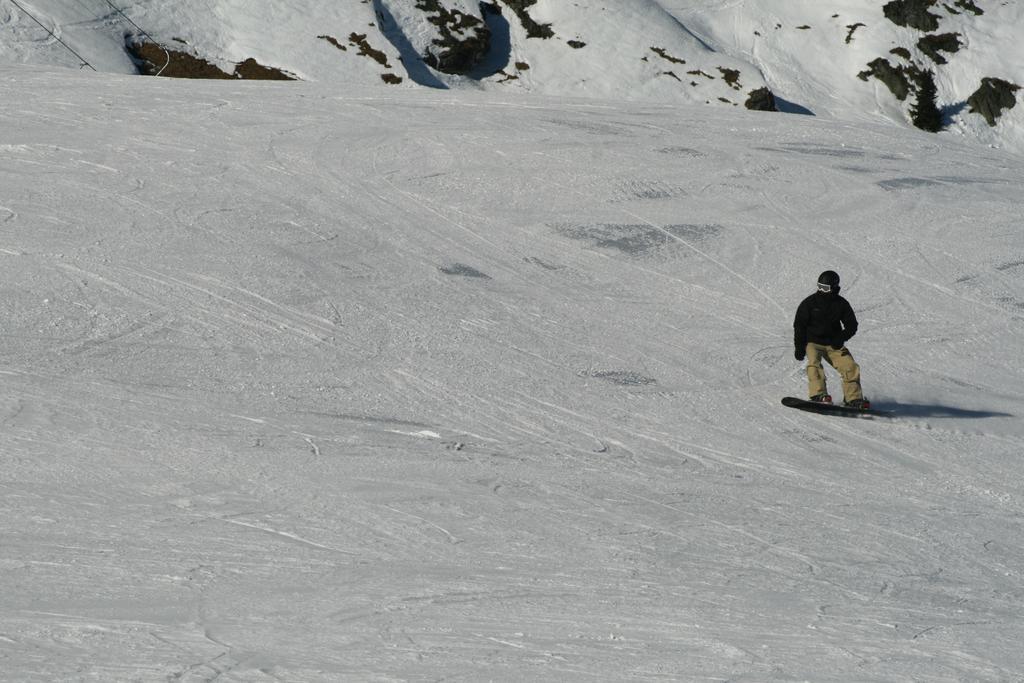Can you describe this image briefly? There is a man wearing gloves and helmet is skating on the ice. In the background there are rocks. 